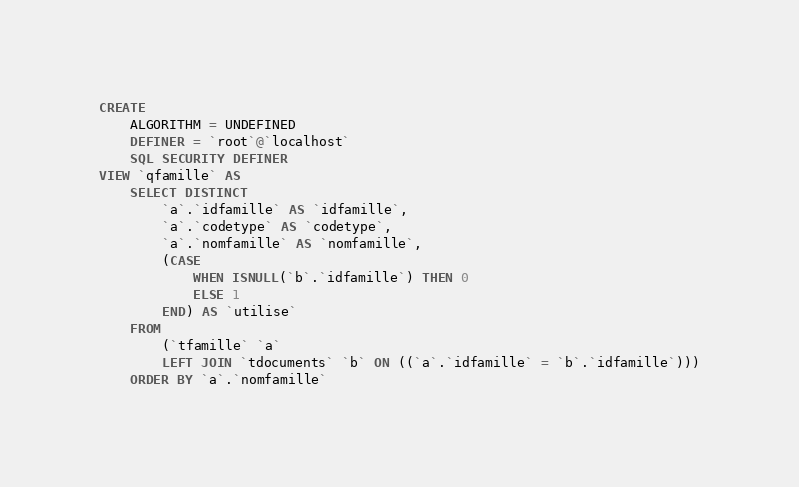<code> <loc_0><loc_0><loc_500><loc_500><_SQL_>CREATE 
    ALGORITHM = UNDEFINED 
    DEFINER = `root`@`localhost` 
    SQL SECURITY DEFINER
VIEW `qfamille` AS
    SELECT DISTINCT
        `a`.`idfamille` AS `idfamille`,
        `a`.`codetype` AS `codetype`,
        `a`.`nomfamille` AS `nomfamille`,
        (CASE
            WHEN ISNULL(`b`.`idfamille`) THEN 0
            ELSE 1
        END) AS `utilise`
    FROM
        (`tfamille` `a`
        LEFT JOIN `tdocuments` `b` ON ((`a`.`idfamille` = `b`.`idfamille`)))
    ORDER BY `a`.`nomfamille`</code> 